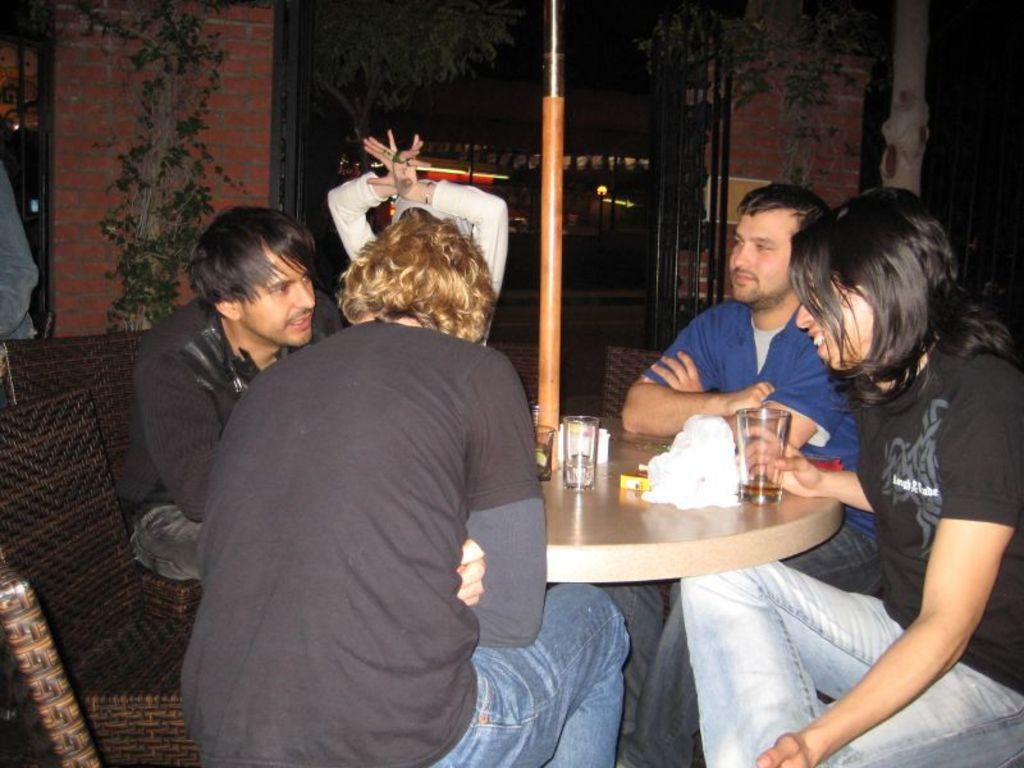What are the people in the image doing? There is a group of people sitting in the image. What can be seen in the background of the image? There are trees and a red wall in the background of the image. Is there a tiger present in the image? No, there is no tiger present in the image. What level of respect can be observed among the people in the image? The level of respect among the people in the image cannot be determined from the image itself. 